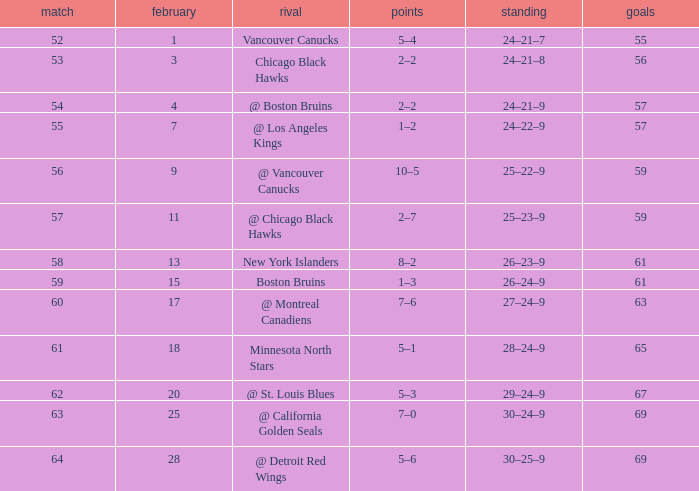Which opponent has a game larger than 61, february smaller than 28, and fewer points than 69? @ St. Louis Blues. 